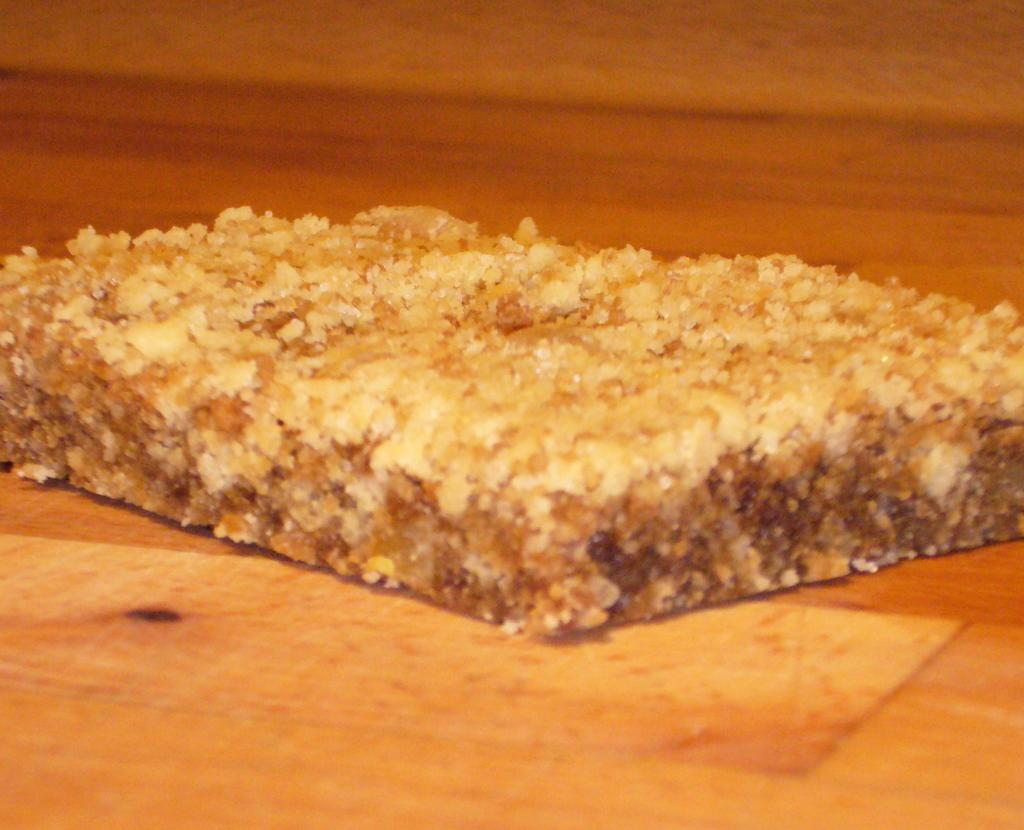What is the main subject of the image? There is a food item in the image. What is the color of the surface on which the food item is placed? The food item is on a brown color surface. What colors can be seen on the food item itself? The food item has cream and brown colors. Can you tell me how the food item is involved in a fight in the image? There is no fight depicted in the image, and the food item is not involved in any conflict. 